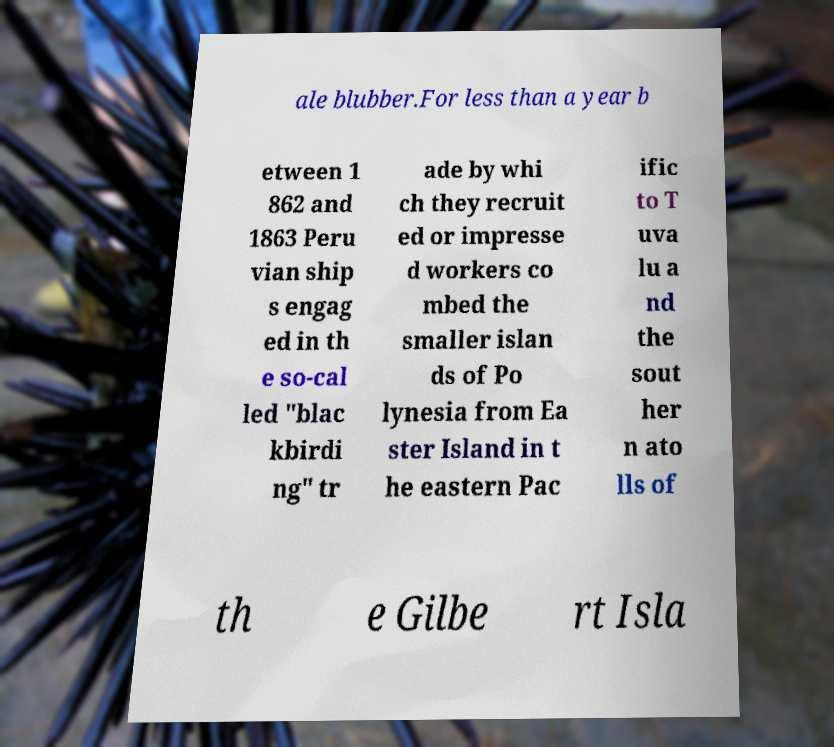There's text embedded in this image that I need extracted. Can you transcribe it verbatim? ale blubber.For less than a year b etween 1 862 and 1863 Peru vian ship s engag ed in th e so-cal led "blac kbirdi ng" tr ade by whi ch they recruit ed or impresse d workers co mbed the smaller islan ds of Po lynesia from Ea ster Island in t he eastern Pac ific to T uva lu a nd the sout her n ato lls of th e Gilbe rt Isla 